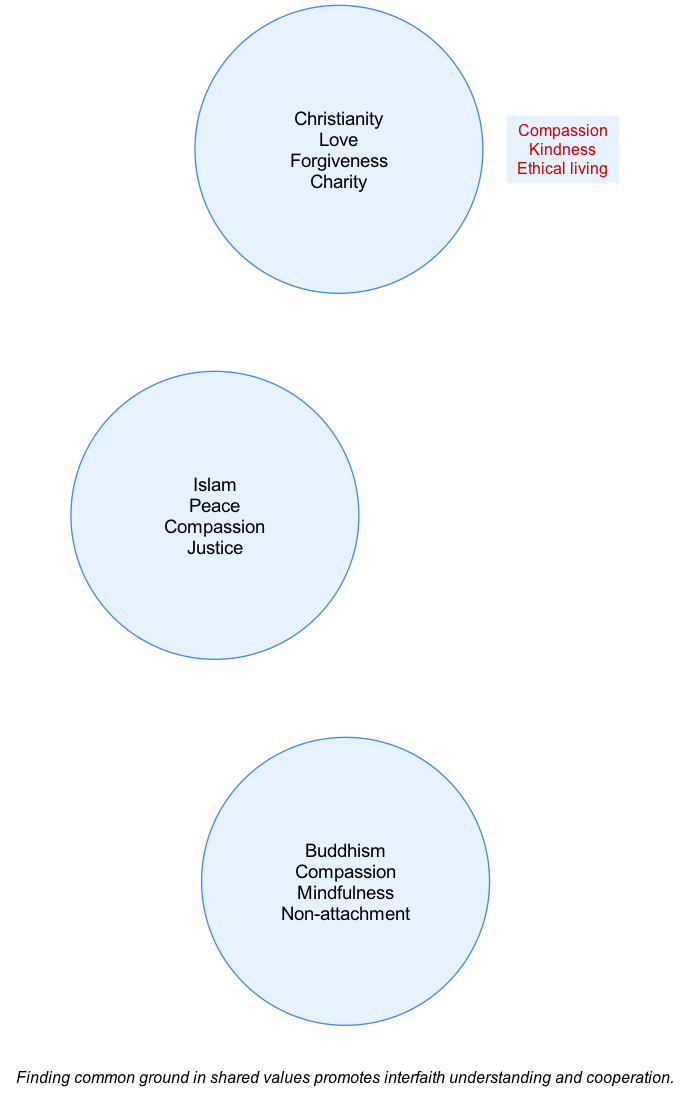What are the three key values of Christianity? According to the diagram, the values listed under Christianity are Love, Forgiveness, and Charity. To find the answer, I look specifically at the circle representing Christianity, which contains the corresponding values listed below its name.
Answer: Love, Forgiveness, Charity Which religions share the value of Compassion? The diagram shows that Compassion is a value shared by Christianity, Islam, and Buddhism, as it appears within the area where all three circles overlap. By checking the intersections, I see that Compassion is included in the values for the intersection of all three religions.
Answer: Christianity, Islam, Buddhism What is one value that is unique to Islam? Looking at the Islam circle, the unique value not found in other religious circles is Justice. By examining the list of values for each religion, I notice that Justice appears only under Islam's list.
Answer: Justice How many intersections are there in the diagram? The diagram includes four intersections; these are represented by the connections where two or more circles overlap. I can count the intersections listed: one for all three religions, one for Christianity and Islam, one for Islam and Buddhism, and one for Christianity and Buddhism.
Answer: Four Which two religions share the values of Inner peace and Self-discipline? Inner peace and Self-discipline are listed in the intersection between Islam and Buddhism. By looking closely at the section of the diagram where these two religions intersect, I can see that these two values are common only between them.
Answer: Islam, Buddhism What value appears in the intersection of Christianity and Buddhism? The diagram indicates that Meditation and Non-violence are shared values in the intersection of Christianity and Buddhism. To find this, I focus on the portion where both circles for Christianity and Buddhism overlap and read the listed values.
Answer: Meditation, Non-violence What is the main purpose of emphasizing shared values in the note? The note emphasizes that finding common ground in shared values promotes interfaith understanding and cooperation. By reading the note at the bottom of the diagram, it's clear that the objective is to highlight the importance of these shared values for fostering better relationships among faiths.
Answer: Interfaith understanding and cooperation How many values are shared by all three religions? There are three values shared among all three religions, which are Compassion, Kindness, and Ethical living. When I examine the center area of the diagram where all circles converge, I can count these values listed there.
Answer: Three 